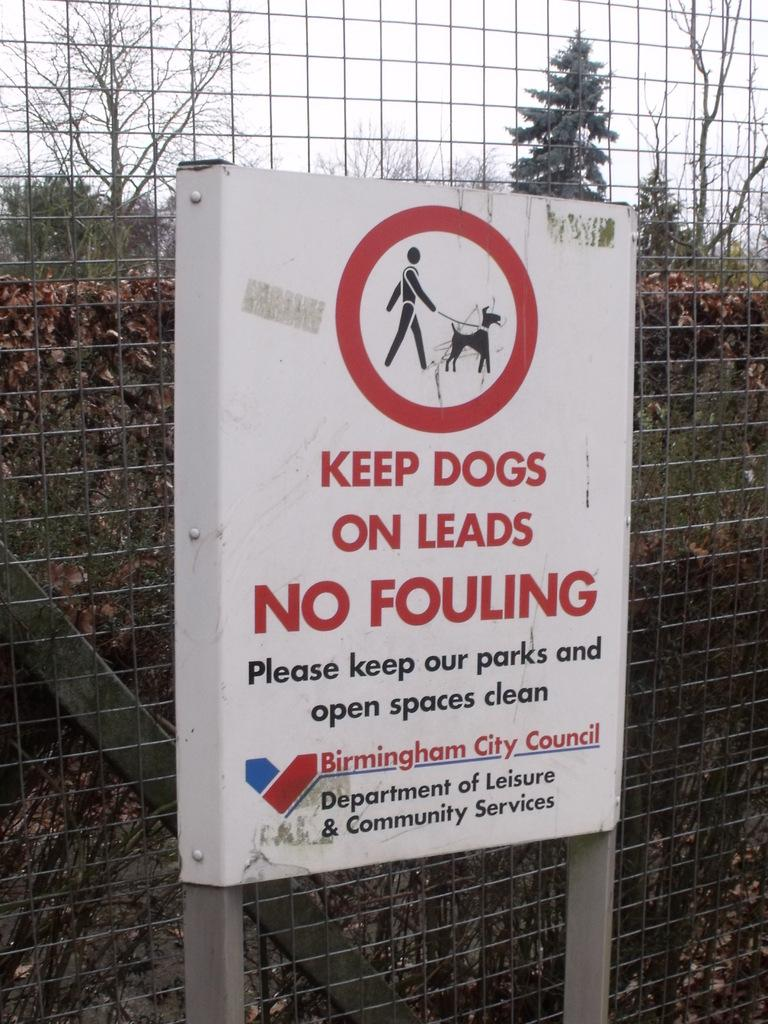What is the main object in the foreground of the image? There is a white board in the image. What is located behind the white board? There is a metal fencing behind the board. What can be seen in the background of the image? There are trees and plants in the background of the image. What is visible at the top of the image? The sky is visible at the top of the image. How many basketballs can be seen on the white board in the image? There are no basketballs present in the image. What type of peace symbol is depicted on the white board? There is no peace symbol or any other symbol on the white board in the image. 